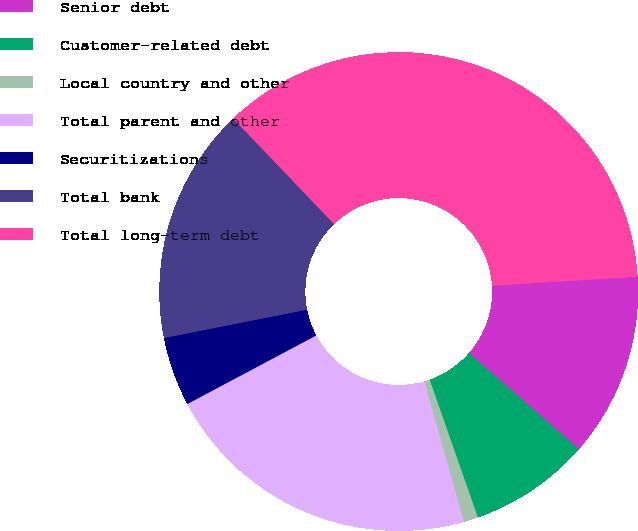Convert chart. <chart><loc_0><loc_0><loc_500><loc_500><pie_chart><fcel>Senior debt<fcel>Customer-related debt<fcel>Local country and other<fcel>Total parent and other<fcel>Securitizations<fcel>Total bank<fcel>Total long-term debt<nl><fcel>12.44%<fcel>8.19%<fcel>0.97%<fcel>21.61%<fcel>4.67%<fcel>15.96%<fcel>36.16%<nl></chart> 